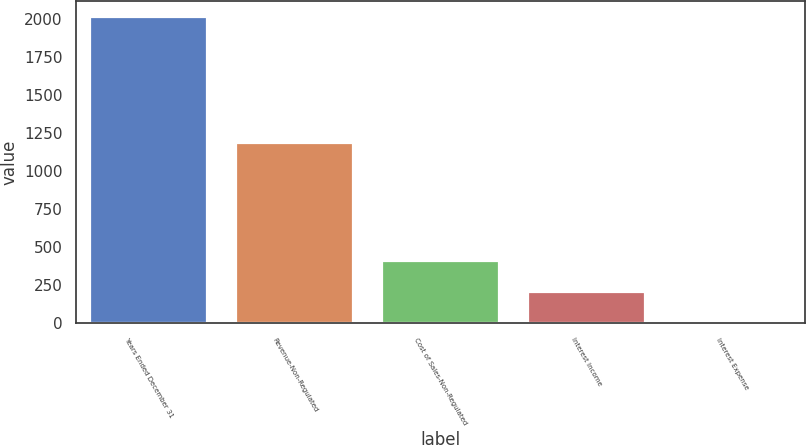Convert chart to OTSL. <chart><loc_0><loc_0><loc_500><loc_500><bar_chart><fcel>Years Ended December 31<fcel>Revenue-Non-Regulated<fcel>Cost of Sales-Non-Regulated<fcel>Interest Income<fcel>Interest Expense<nl><fcel>2014<fcel>1188<fcel>410<fcel>209.5<fcel>9<nl></chart> 